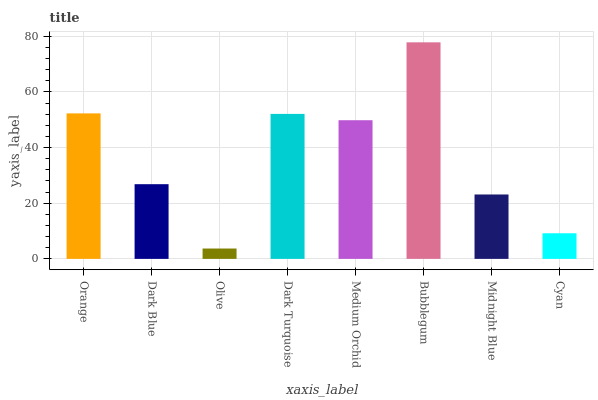Is Dark Blue the minimum?
Answer yes or no. No. Is Dark Blue the maximum?
Answer yes or no. No. Is Orange greater than Dark Blue?
Answer yes or no. Yes. Is Dark Blue less than Orange?
Answer yes or no. Yes. Is Dark Blue greater than Orange?
Answer yes or no. No. Is Orange less than Dark Blue?
Answer yes or no. No. Is Medium Orchid the high median?
Answer yes or no. Yes. Is Dark Blue the low median?
Answer yes or no. Yes. Is Dark Blue the high median?
Answer yes or no. No. Is Dark Turquoise the low median?
Answer yes or no. No. 